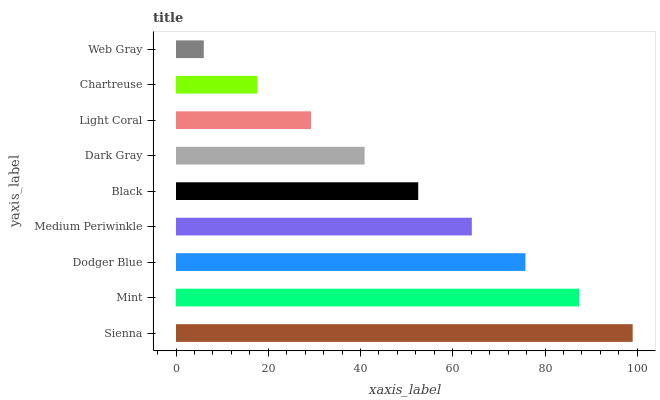Is Web Gray the minimum?
Answer yes or no. Yes. Is Sienna the maximum?
Answer yes or no. Yes. Is Mint the minimum?
Answer yes or no. No. Is Mint the maximum?
Answer yes or no. No. Is Sienna greater than Mint?
Answer yes or no. Yes. Is Mint less than Sienna?
Answer yes or no. Yes. Is Mint greater than Sienna?
Answer yes or no. No. Is Sienna less than Mint?
Answer yes or no. No. Is Black the high median?
Answer yes or no. Yes. Is Black the low median?
Answer yes or no. Yes. Is Light Coral the high median?
Answer yes or no. No. Is Sienna the low median?
Answer yes or no. No. 